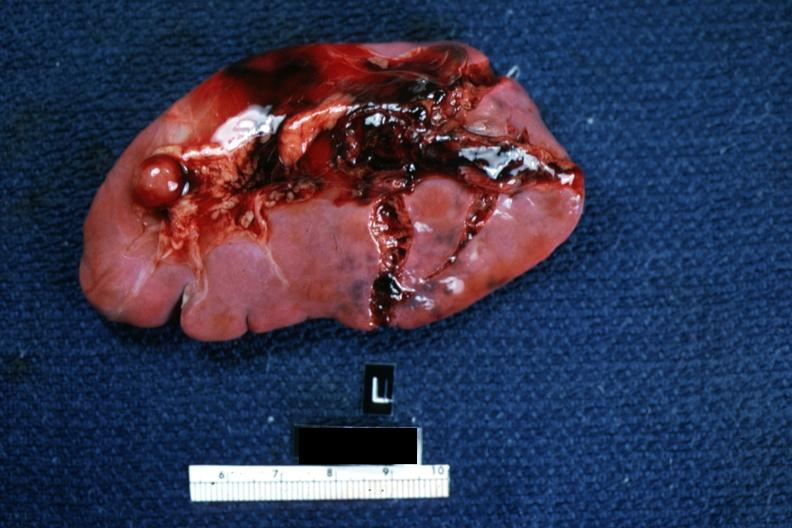s hematologic present?
Answer the question using a single word or phrase. Yes 